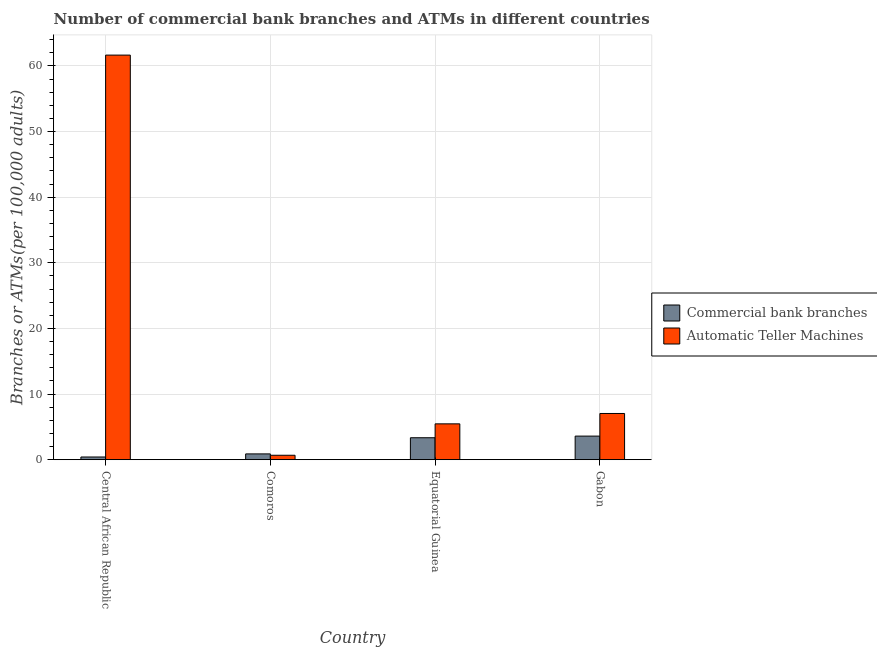How many different coloured bars are there?
Provide a succinct answer. 2. Are the number of bars on each tick of the X-axis equal?
Offer a terse response. Yes. How many bars are there on the 1st tick from the left?
Offer a very short reply. 2. How many bars are there on the 4th tick from the right?
Your answer should be compact. 2. What is the label of the 2nd group of bars from the left?
Provide a succinct answer. Comoros. In how many cases, is the number of bars for a given country not equal to the number of legend labels?
Your answer should be very brief. 0. What is the number of commercal bank branches in Central African Republic?
Provide a succinct answer. 0.41. Across all countries, what is the maximum number of commercal bank branches?
Give a very brief answer. 3.6. Across all countries, what is the minimum number of commercal bank branches?
Your answer should be compact. 0.41. In which country was the number of atms maximum?
Keep it short and to the point. Central African Republic. In which country was the number of atms minimum?
Make the answer very short. Comoros. What is the total number of commercal bank branches in the graph?
Give a very brief answer. 8.24. What is the difference between the number of atms in Equatorial Guinea and that in Gabon?
Offer a very short reply. -1.58. What is the difference between the number of commercal bank branches in Central African Republic and the number of atms in Gabon?
Your response must be concise. -6.63. What is the average number of atms per country?
Offer a very short reply. 18.71. What is the difference between the number of commercal bank branches and number of atms in Gabon?
Ensure brevity in your answer.  -3.45. What is the ratio of the number of commercal bank branches in Central African Republic to that in Comoros?
Provide a succinct answer. 0.47. Is the number of atms in Comoros less than that in Gabon?
Keep it short and to the point. Yes. Is the difference between the number of atms in Comoros and Equatorial Guinea greater than the difference between the number of commercal bank branches in Comoros and Equatorial Guinea?
Your answer should be very brief. No. What is the difference between the highest and the second highest number of commercal bank branches?
Ensure brevity in your answer.  0.25. What is the difference between the highest and the lowest number of atms?
Your answer should be very brief. 60.98. What does the 2nd bar from the left in Gabon represents?
Ensure brevity in your answer.  Automatic Teller Machines. What does the 2nd bar from the right in Comoros represents?
Provide a succinct answer. Commercial bank branches. Are all the bars in the graph horizontal?
Offer a very short reply. No. How many countries are there in the graph?
Give a very brief answer. 4. What is the difference between two consecutive major ticks on the Y-axis?
Your answer should be very brief. 10. Does the graph contain grids?
Your answer should be very brief. Yes. Where does the legend appear in the graph?
Your answer should be very brief. Center right. How many legend labels are there?
Provide a short and direct response. 2. What is the title of the graph?
Your answer should be very brief. Number of commercial bank branches and ATMs in different countries. What is the label or title of the X-axis?
Offer a very short reply. Country. What is the label or title of the Y-axis?
Ensure brevity in your answer.  Branches or ATMs(per 100,0 adults). What is the Branches or ATMs(per 100,000 adults) of Commercial bank branches in Central African Republic?
Offer a terse response. 0.41. What is the Branches or ATMs(per 100,000 adults) of Automatic Teller Machines in Central African Republic?
Ensure brevity in your answer.  61.66. What is the Branches or ATMs(per 100,000 adults) of Commercial bank branches in Comoros?
Offer a very short reply. 0.88. What is the Branches or ATMs(per 100,000 adults) of Automatic Teller Machines in Comoros?
Provide a short and direct response. 0.68. What is the Branches or ATMs(per 100,000 adults) of Commercial bank branches in Equatorial Guinea?
Provide a short and direct response. 3.35. What is the Branches or ATMs(per 100,000 adults) in Automatic Teller Machines in Equatorial Guinea?
Make the answer very short. 5.46. What is the Branches or ATMs(per 100,000 adults) in Commercial bank branches in Gabon?
Provide a succinct answer. 3.6. What is the Branches or ATMs(per 100,000 adults) in Automatic Teller Machines in Gabon?
Provide a succinct answer. 7.04. Across all countries, what is the maximum Branches or ATMs(per 100,000 adults) of Commercial bank branches?
Ensure brevity in your answer.  3.6. Across all countries, what is the maximum Branches or ATMs(per 100,000 adults) of Automatic Teller Machines?
Offer a very short reply. 61.66. Across all countries, what is the minimum Branches or ATMs(per 100,000 adults) of Commercial bank branches?
Provide a short and direct response. 0.41. Across all countries, what is the minimum Branches or ATMs(per 100,000 adults) of Automatic Teller Machines?
Your response must be concise. 0.68. What is the total Branches or ATMs(per 100,000 adults) in Commercial bank branches in the graph?
Your response must be concise. 8.24. What is the total Branches or ATMs(per 100,000 adults) of Automatic Teller Machines in the graph?
Give a very brief answer. 74.84. What is the difference between the Branches or ATMs(per 100,000 adults) of Commercial bank branches in Central African Republic and that in Comoros?
Your answer should be very brief. -0.47. What is the difference between the Branches or ATMs(per 100,000 adults) of Automatic Teller Machines in Central African Republic and that in Comoros?
Ensure brevity in your answer.  60.98. What is the difference between the Branches or ATMs(per 100,000 adults) of Commercial bank branches in Central African Republic and that in Equatorial Guinea?
Ensure brevity in your answer.  -2.93. What is the difference between the Branches or ATMs(per 100,000 adults) of Automatic Teller Machines in Central African Republic and that in Equatorial Guinea?
Provide a succinct answer. 56.2. What is the difference between the Branches or ATMs(per 100,000 adults) in Commercial bank branches in Central African Republic and that in Gabon?
Provide a succinct answer. -3.19. What is the difference between the Branches or ATMs(per 100,000 adults) of Automatic Teller Machines in Central African Republic and that in Gabon?
Offer a terse response. 54.61. What is the difference between the Branches or ATMs(per 100,000 adults) of Commercial bank branches in Comoros and that in Equatorial Guinea?
Offer a very short reply. -2.46. What is the difference between the Branches or ATMs(per 100,000 adults) of Automatic Teller Machines in Comoros and that in Equatorial Guinea?
Your answer should be compact. -4.79. What is the difference between the Branches or ATMs(per 100,000 adults) in Commercial bank branches in Comoros and that in Gabon?
Give a very brief answer. -2.71. What is the difference between the Branches or ATMs(per 100,000 adults) in Automatic Teller Machines in Comoros and that in Gabon?
Offer a terse response. -6.37. What is the difference between the Branches or ATMs(per 100,000 adults) in Commercial bank branches in Equatorial Guinea and that in Gabon?
Keep it short and to the point. -0.25. What is the difference between the Branches or ATMs(per 100,000 adults) of Automatic Teller Machines in Equatorial Guinea and that in Gabon?
Give a very brief answer. -1.58. What is the difference between the Branches or ATMs(per 100,000 adults) of Commercial bank branches in Central African Republic and the Branches or ATMs(per 100,000 adults) of Automatic Teller Machines in Comoros?
Your answer should be very brief. -0.26. What is the difference between the Branches or ATMs(per 100,000 adults) of Commercial bank branches in Central African Republic and the Branches or ATMs(per 100,000 adults) of Automatic Teller Machines in Equatorial Guinea?
Make the answer very short. -5.05. What is the difference between the Branches or ATMs(per 100,000 adults) in Commercial bank branches in Central African Republic and the Branches or ATMs(per 100,000 adults) in Automatic Teller Machines in Gabon?
Ensure brevity in your answer.  -6.63. What is the difference between the Branches or ATMs(per 100,000 adults) in Commercial bank branches in Comoros and the Branches or ATMs(per 100,000 adults) in Automatic Teller Machines in Equatorial Guinea?
Provide a succinct answer. -4.58. What is the difference between the Branches or ATMs(per 100,000 adults) of Commercial bank branches in Comoros and the Branches or ATMs(per 100,000 adults) of Automatic Teller Machines in Gabon?
Make the answer very short. -6.16. What is the difference between the Branches or ATMs(per 100,000 adults) in Commercial bank branches in Equatorial Guinea and the Branches or ATMs(per 100,000 adults) in Automatic Teller Machines in Gabon?
Your response must be concise. -3.7. What is the average Branches or ATMs(per 100,000 adults) in Commercial bank branches per country?
Provide a short and direct response. 2.06. What is the average Branches or ATMs(per 100,000 adults) of Automatic Teller Machines per country?
Offer a very short reply. 18.71. What is the difference between the Branches or ATMs(per 100,000 adults) in Commercial bank branches and Branches or ATMs(per 100,000 adults) in Automatic Teller Machines in Central African Republic?
Ensure brevity in your answer.  -61.25. What is the difference between the Branches or ATMs(per 100,000 adults) in Commercial bank branches and Branches or ATMs(per 100,000 adults) in Automatic Teller Machines in Comoros?
Your answer should be compact. 0.21. What is the difference between the Branches or ATMs(per 100,000 adults) in Commercial bank branches and Branches or ATMs(per 100,000 adults) in Automatic Teller Machines in Equatorial Guinea?
Make the answer very short. -2.12. What is the difference between the Branches or ATMs(per 100,000 adults) of Commercial bank branches and Branches or ATMs(per 100,000 adults) of Automatic Teller Machines in Gabon?
Ensure brevity in your answer.  -3.45. What is the ratio of the Branches or ATMs(per 100,000 adults) in Commercial bank branches in Central African Republic to that in Comoros?
Ensure brevity in your answer.  0.47. What is the ratio of the Branches or ATMs(per 100,000 adults) in Automatic Teller Machines in Central African Republic to that in Comoros?
Keep it short and to the point. 91.18. What is the ratio of the Branches or ATMs(per 100,000 adults) in Commercial bank branches in Central African Republic to that in Equatorial Guinea?
Ensure brevity in your answer.  0.12. What is the ratio of the Branches or ATMs(per 100,000 adults) in Automatic Teller Machines in Central African Republic to that in Equatorial Guinea?
Your answer should be compact. 11.29. What is the ratio of the Branches or ATMs(per 100,000 adults) of Commercial bank branches in Central African Republic to that in Gabon?
Give a very brief answer. 0.11. What is the ratio of the Branches or ATMs(per 100,000 adults) in Automatic Teller Machines in Central African Republic to that in Gabon?
Offer a very short reply. 8.75. What is the ratio of the Branches or ATMs(per 100,000 adults) in Commercial bank branches in Comoros to that in Equatorial Guinea?
Make the answer very short. 0.26. What is the ratio of the Branches or ATMs(per 100,000 adults) in Automatic Teller Machines in Comoros to that in Equatorial Guinea?
Ensure brevity in your answer.  0.12. What is the ratio of the Branches or ATMs(per 100,000 adults) in Commercial bank branches in Comoros to that in Gabon?
Your response must be concise. 0.25. What is the ratio of the Branches or ATMs(per 100,000 adults) of Automatic Teller Machines in Comoros to that in Gabon?
Make the answer very short. 0.1. What is the ratio of the Branches or ATMs(per 100,000 adults) of Commercial bank branches in Equatorial Guinea to that in Gabon?
Provide a succinct answer. 0.93. What is the ratio of the Branches or ATMs(per 100,000 adults) in Automatic Teller Machines in Equatorial Guinea to that in Gabon?
Offer a very short reply. 0.78. What is the difference between the highest and the second highest Branches or ATMs(per 100,000 adults) of Commercial bank branches?
Give a very brief answer. 0.25. What is the difference between the highest and the second highest Branches or ATMs(per 100,000 adults) in Automatic Teller Machines?
Provide a short and direct response. 54.61. What is the difference between the highest and the lowest Branches or ATMs(per 100,000 adults) in Commercial bank branches?
Offer a very short reply. 3.19. What is the difference between the highest and the lowest Branches or ATMs(per 100,000 adults) in Automatic Teller Machines?
Make the answer very short. 60.98. 